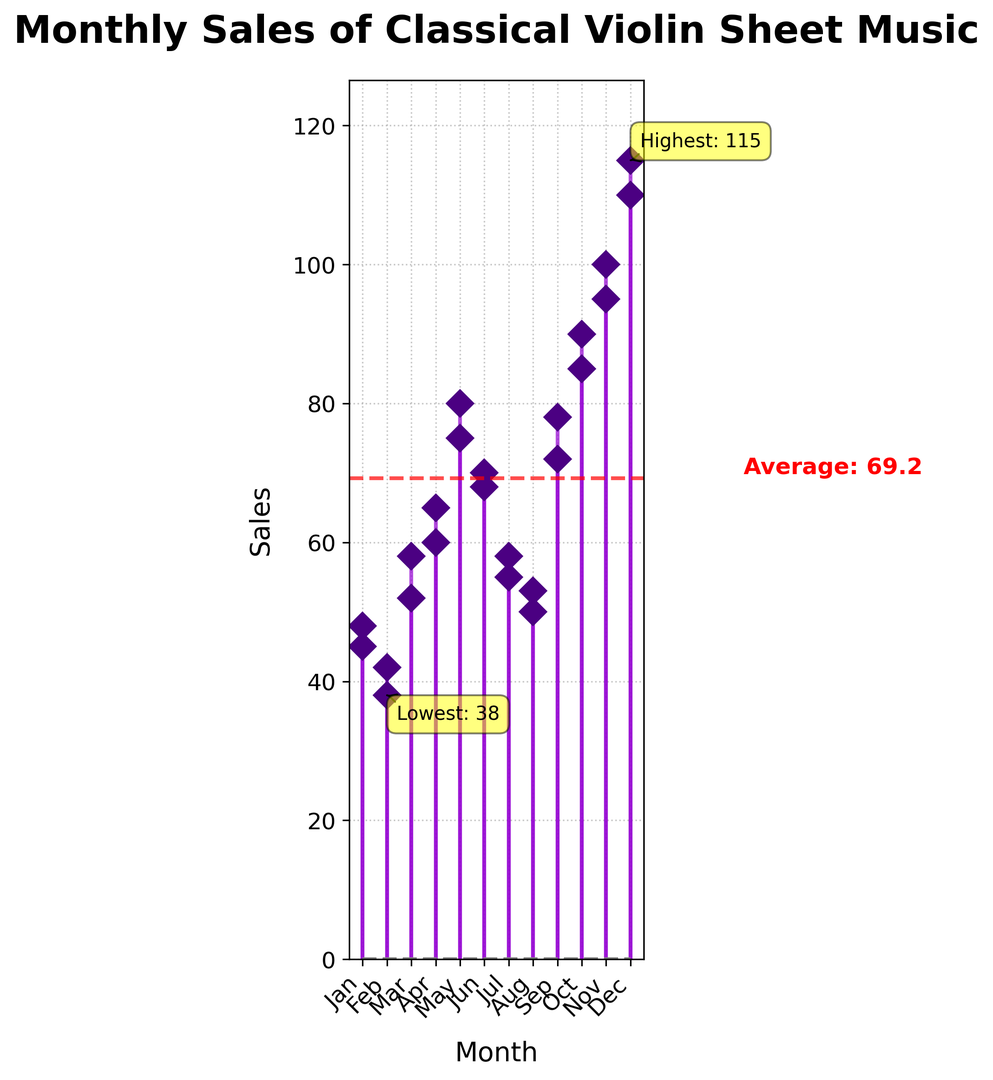What is the highest monthly sales figure? To determine the highest monthly sales, find the tallest point on the stem plot or the annotated "Highest" label. The highest sales figure is clearly marked in a yellow box.
Answer: 115 When do the highest and the lowest sales months occur? The "Highest" and "Lowest" annotations on the stem plot show the months when these values occurred. The highest sales occurred in December, and the lowest in February.
Answer: December and February What is the average monthly sales? The average sales is represented by a red dashed line and is annotated with a text label next to the line. According to the plot, the average sales value is around 68.1.
Answer: 68.1 By how much do the sales increase from February to March in the second year? Locate the sales values for February and March of the second year and calculate the difference between them. February has 42 sales and March has 58 sales. The increase is 58 - 42 = 16.
Answer: 16 Which month shows the greatest sales increase compared to the previous month? Scan through the plot comparing the increase in sales month-over-month. The biggest jump appears between October and November in the second year, jumping from 90 to 100 sales, an increase of 10.
Answer: November In which months do sales surpass the average monthly sales? Identify the months where the sales bars exceed the red dashed average line. Months exceeding the average are May, June, September, October, November, and December in both years.
Answer: May, June, September, October, November, December How many times does the sales figure for a month fall below 50? Count how many data points fall below the sales value of 50. Based on the figure, the values below 50 occur in January and February for both years.
Answer: 4 Is the sales trend generally increasing or decreasing over the two years? Consider the overall direction of the sales lines from the start to the end of the time period. Despite some fluctuations, the general trend from January of the first year to December of the second year shows an increasing pattern.
Answer: Increasing What is the difference between the highest and lowest sales figures? The highest sales is 115 in December, and the lowest is 38 in February. The difference is 115 - 38 = 77.
Answer: 77 